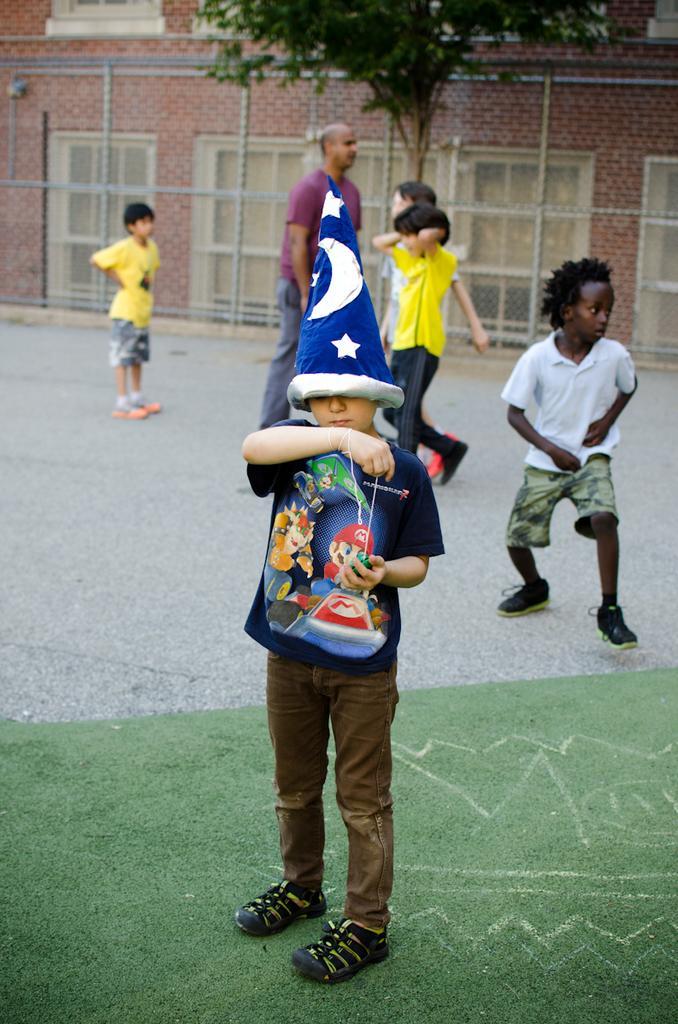Please provide a concise description of this image. In this image I can see few people around. In the background I can see the wall, windows, fencing and the tree. 